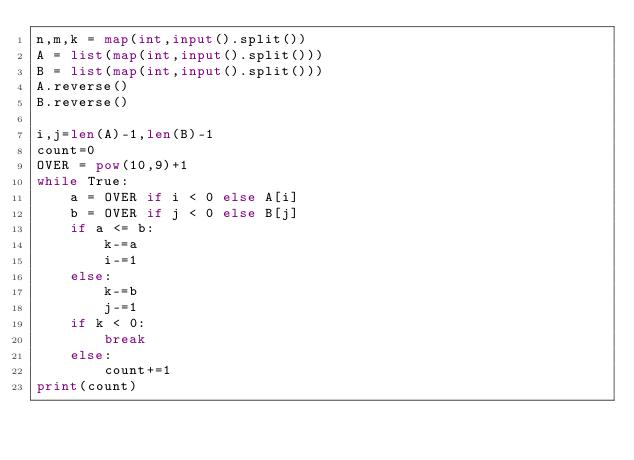Convert code to text. <code><loc_0><loc_0><loc_500><loc_500><_Python_>n,m,k = map(int,input().split())
A = list(map(int,input().split()))
B = list(map(int,input().split()))
A.reverse()
B.reverse()

i,j=len(A)-1,len(B)-1
count=0
OVER = pow(10,9)+1
while True:
    a = OVER if i < 0 else A[i]
    b = OVER if j < 0 else B[j]
    if a <= b:
        k-=a
        i-=1
    else:
        k-=b
        j-=1
    if k < 0:
        break
    else:
        count+=1
print(count)</code> 